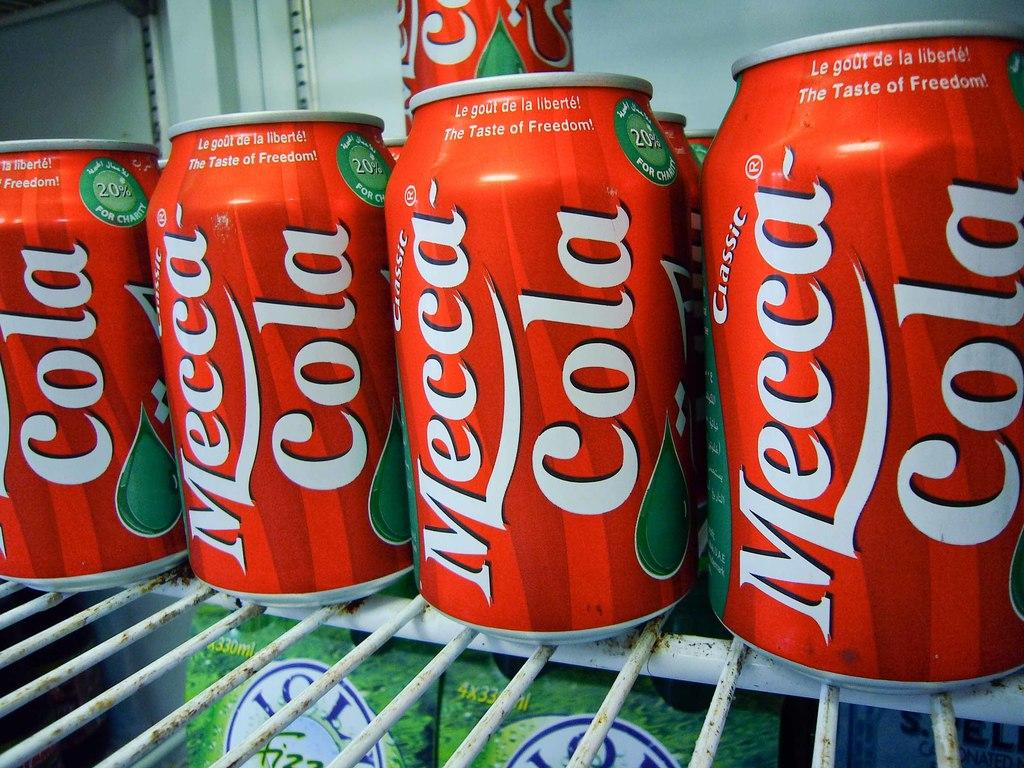<image>
Summarize the visual content of the image. Bunch of cans of Mecca Cola that is in a red can 